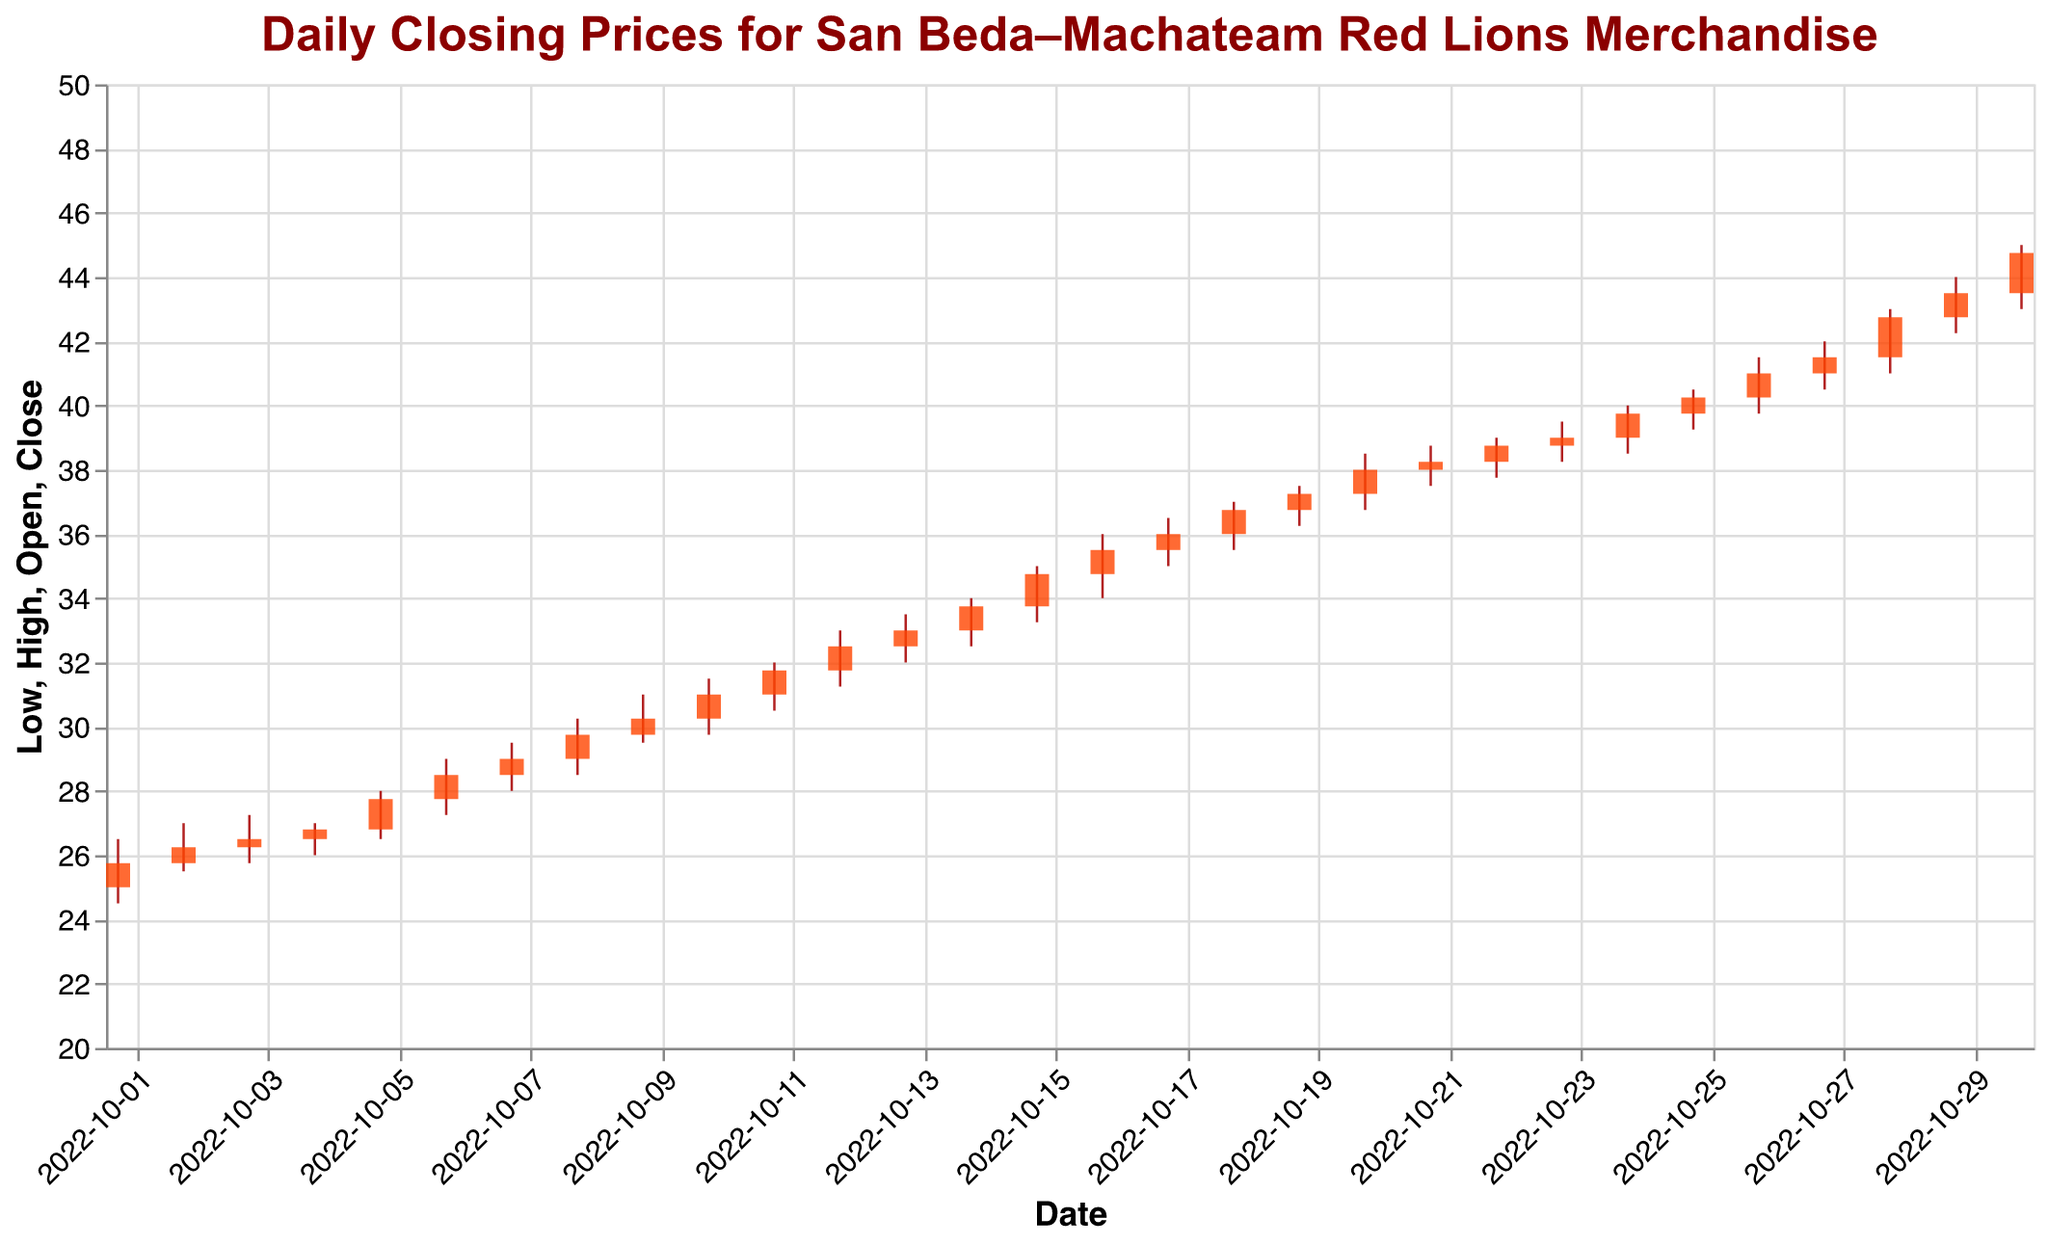What is the highest closing price observed in the data? The highest closing price can be found by looking at the top of the candlestick plots. The highest closing price is found on 2022-10-30, which is 44.75.
Answer: 44.75 On which date did the merchandise price have the lowest high value? To find the date with the lowest high value, examine the top of each candlestick. The lowest high value is 26.50 on 2022-10-01.
Answer: 2022-10-01 What was the volume of sales on 2022-10-10? Find the data for 2022-10-10 and look at the volume column, which is 3400.
Answer: 3400 Between which two dates did the merchandise closing price show the largest increase? Compare the closing prices day by day. The largest increase in closing price from one day to the next is from 2022-10-12 (32.50) to 2022-10-13 (33.00).
Answer: 2022-10-12 to 2022-10-13 How many days had a closing price higher than 40? Count the number of days where the closing price column is greater than 40. Dates: 2022-10-25, 2022-10-26, 2022-10-27, 2022-10-28, 2022-10-29, and 2022-10-30. Total of 6 days.
Answer: 6 What was the median opening price of the merchandise? List all opening prices, sort them, and find the median value:
25.00, 25.75, 26.25, 26.50, 26.80, 27.75, 28.50, 29.00, 29.75, 30.25, 31.00, 31.75, 32.50, 33.00, 33.75, 34.75, 35.50, 36.00, 36.75, 37.25, 38.00, 38.25, 38.75, 39.00, 39.75, 40.25, 41.00, 41.50, 42.75, 43.50. The middle value between the 15th and 16th prices (33.75 and 34.75) is (33.75 + 34.75) / 2 = 34.25.
Answer: 34.25 Which date had the smallest range (High - Low) of the merchandise price? Calculate the range (high - low) for each date and find the smallest value. The ranges are: 2.00, 1.50, 1.50, 1.00, 1.50, 1.75, 1.50, 1.75, 1.50, 1.75, 1.50, 1.75, 1.50, 1.50, 1.75, 2.00, 1.50, 1.50, 1.25, 1.75, 1.25, 1.25, 1.25, 1.50, 1.25, 1.50, 1.50, 2.00, 1.75, 2.00. The smallest range is 1.00 on 2022-10-04.
Answer: 2022-10-04 What were the opening and closing prices on the day with the highest volume of sales? Find the date with the highest volume, which is 2022-10-20 (3900). The opening price on this date was 37.25, and the closing price was 38.00.
Answer: 37.25 and 38.00 How many days had the closing price lower than the opening price? Count the days where the closing price is lower than the corresponding opening price. They are 2022-10-13 and 2022-10-18.
Answer: 2 